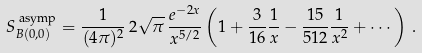Convert formula to latex. <formula><loc_0><loc_0><loc_500><loc_500>S _ { B ( 0 , 0 ) } ^ { \text { asymp} } = \frac { 1 } { ( 4 \pi ) ^ { 2 } } \, 2 \sqrt { \pi } \, \frac { e ^ { - 2 x } } { x ^ { 5 / 2 } } \left ( 1 + \frac { 3 } { 1 6 } \frac { 1 } { x } - \frac { 1 5 } { 5 1 2 } \frac { 1 } { x ^ { 2 } } + \cdots \right ) \, .</formula> 